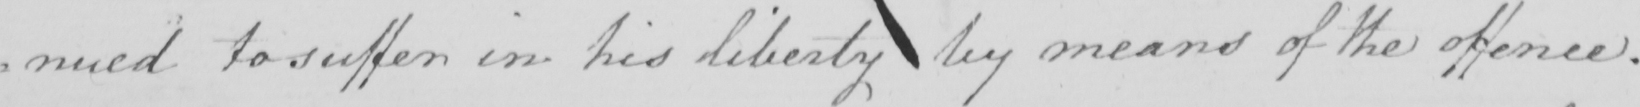Can you read and transcribe this handwriting? : nued to suffer in his Liberty by means of the offence . 